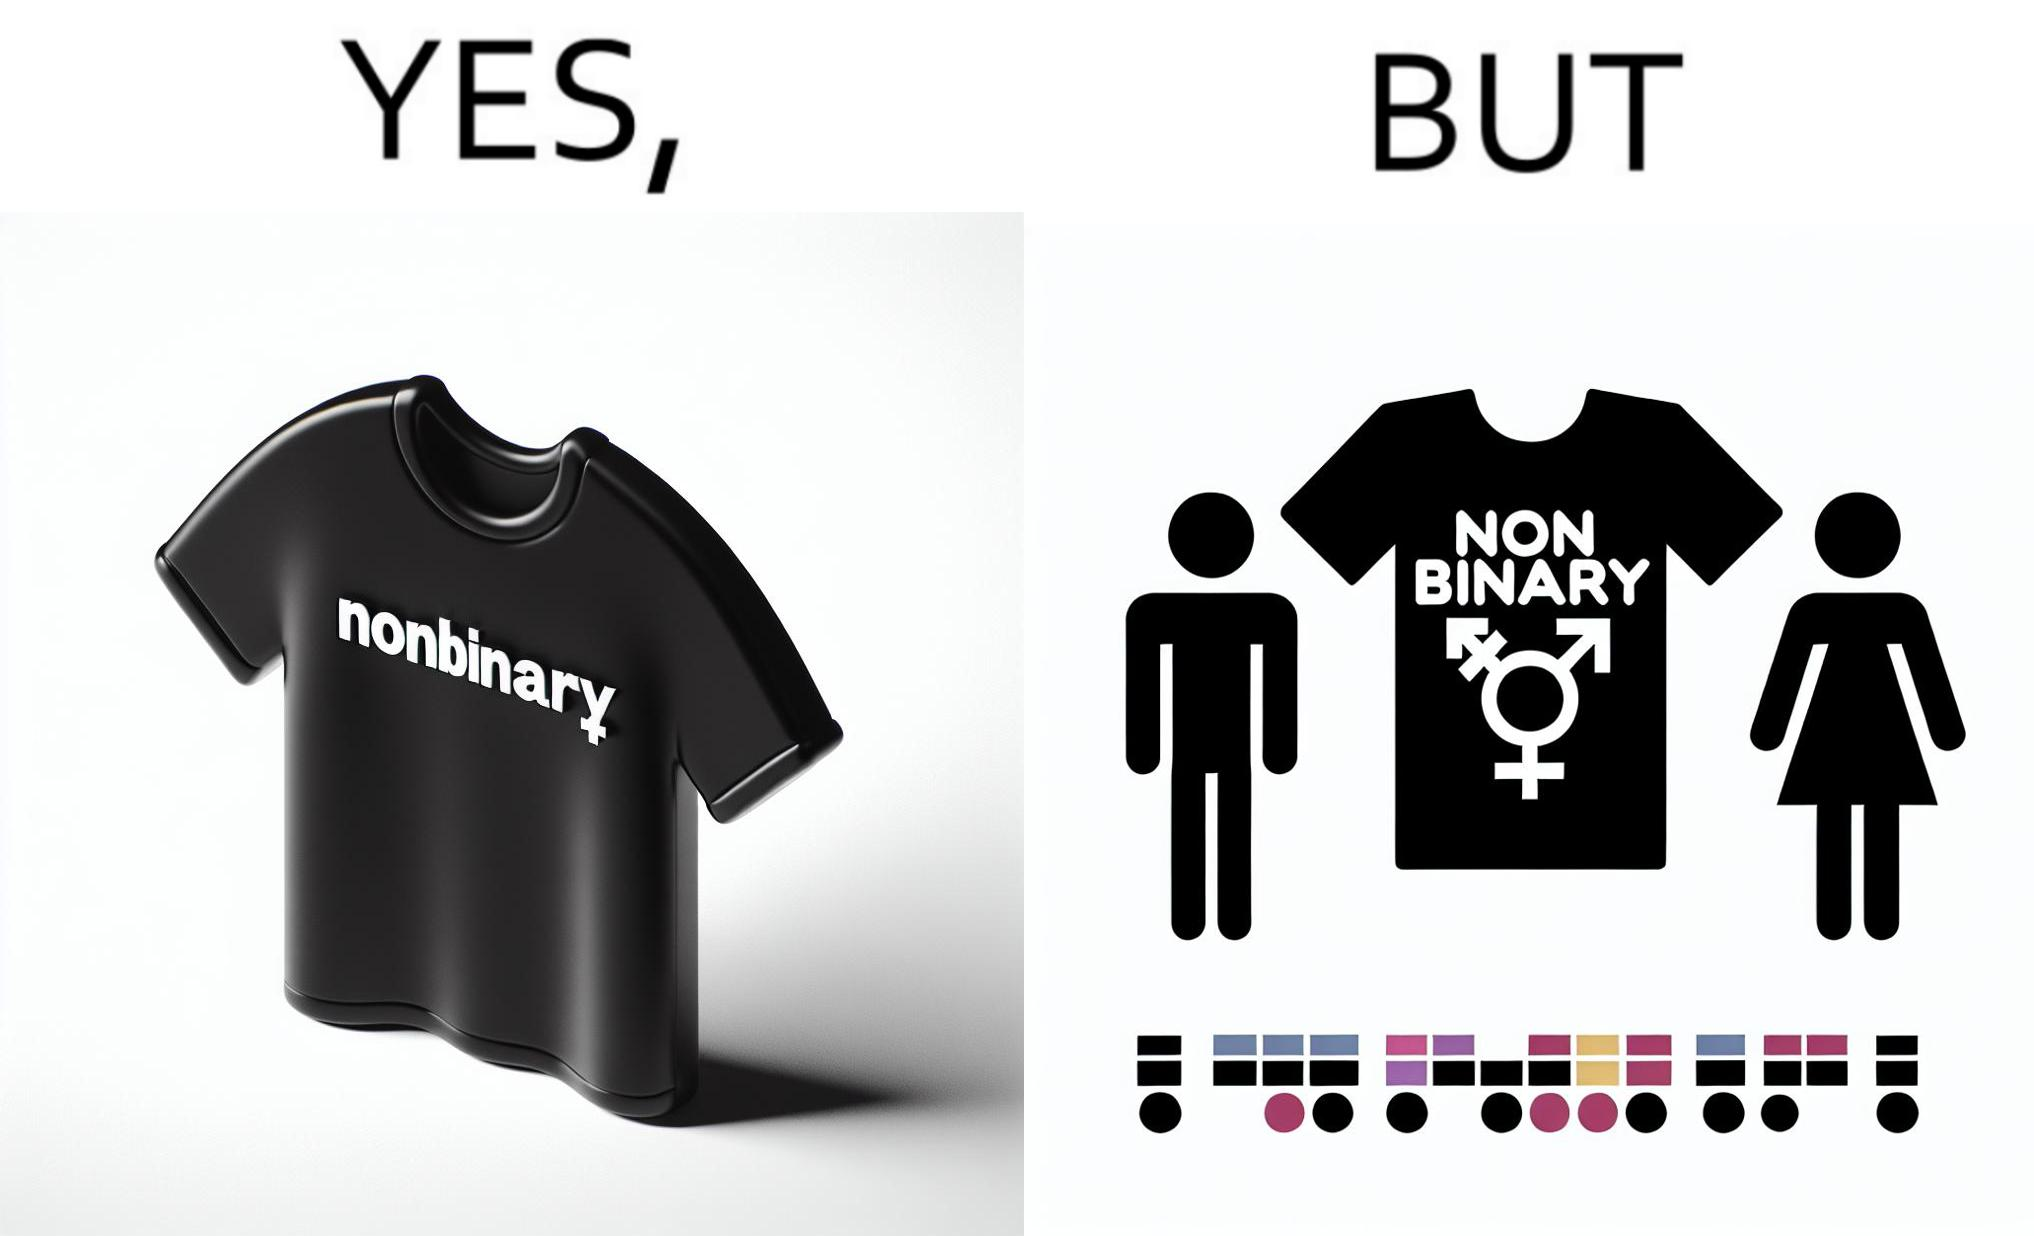Explain the humor or irony in this image. The image is ironic, as the t-shirt that says "NONBINARY" has only 2 options for gender on an online retail forum. 